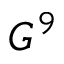Convert formula to latex. <formula><loc_0><loc_0><loc_500><loc_500>G ^ { 9 }</formula> 